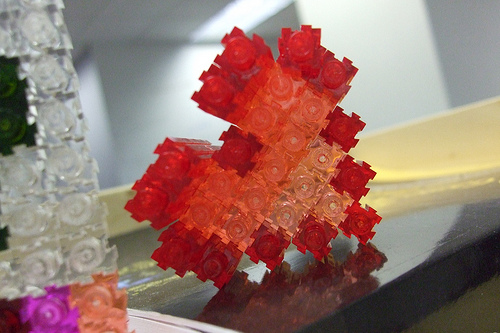<image>
Can you confirm if the crafts is on the table? Yes. Looking at the image, I can see the crafts is positioned on top of the table, with the table providing support. 